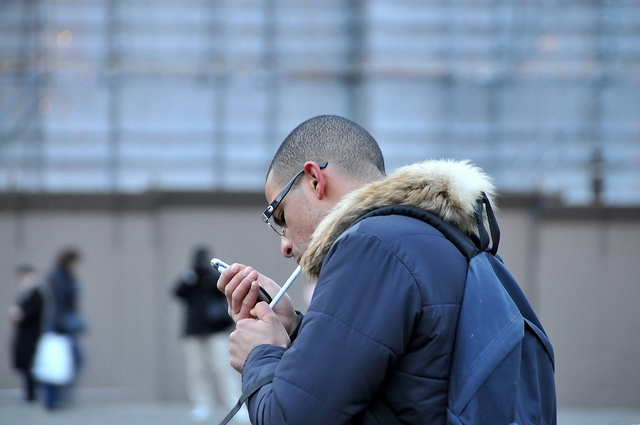Describe the objects in this image and their specific colors. I can see people in gray, navy, darkblue, black, and darkgray tones, backpack in gray, navy, blue, black, and darkblue tones, people in gray, black, darkgray, and lightblue tones, people in gray, navy, darkblue, and black tones, and people in gray and black tones in this image. 